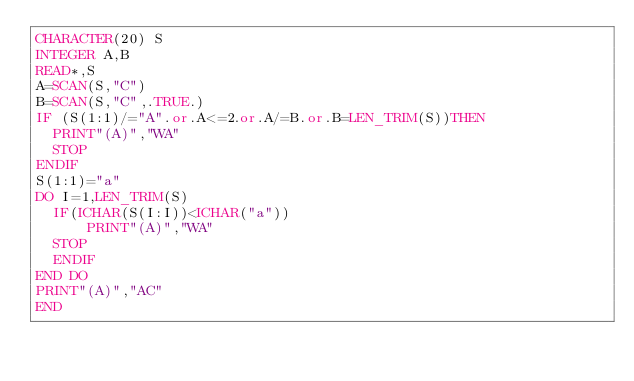Convert code to text. <code><loc_0><loc_0><loc_500><loc_500><_FORTRAN_>CHARACTER(20) S
INTEGER A,B
READ*,S
A=SCAN(S,"C")
B=SCAN(S,"C",.TRUE.)
IF (S(1:1)/="A".or.A<=2.or.A/=B.or.B=LEN_TRIM(S))THEN
  PRINT"(A)","WA"
  STOP
ENDIF
S(1:1)="a"
DO I=1,LEN_TRIM(S)
  IF(ICHAR(S(I:I))<ICHAR("a"))
      PRINT"(A)","WA"
  STOP
  ENDIF
END DO
PRINT"(A)","AC"
END </code> 